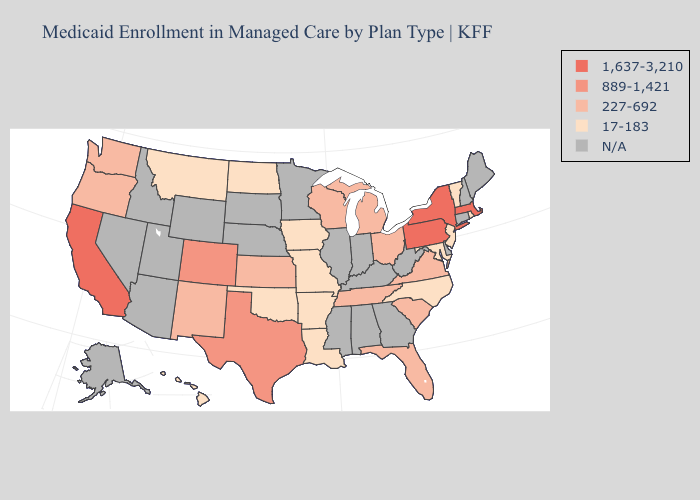How many symbols are there in the legend?
Quick response, please. 5. Among the states that border Oregon , does Washington have the highest value?
Give a very brief answer. No. What is the lowest value in states that border Iowa?
Answer briefly. 17-183. Among the states that border Ohio , does Michigan have the lowest value?
Be succinct. Yes. Does Montana have the highest value in the West?
Quick response, please. No. What is the highest value in the Northeast ?
Write a very short answer. 1,637-3,210. Among the states that border Wyoming , does Colorado have the highest value?
Concise answer only. Yes. Which states hav the highest value in the MidWest?
Keep it brief. Kansas, Michigan, Ohio, Wisconsin. What is the value of Pennsylvania?
Short answer required. 1,637-3,210. What is the value of Georgia?
Keep it brief. N/A. What is the highest value in the USA?
Answer briefly. 1,637-3,210. What is the value of Texas?
Be succinct. 889-1,421. What is the value of Georgia?
Concise answer only. N/A. 